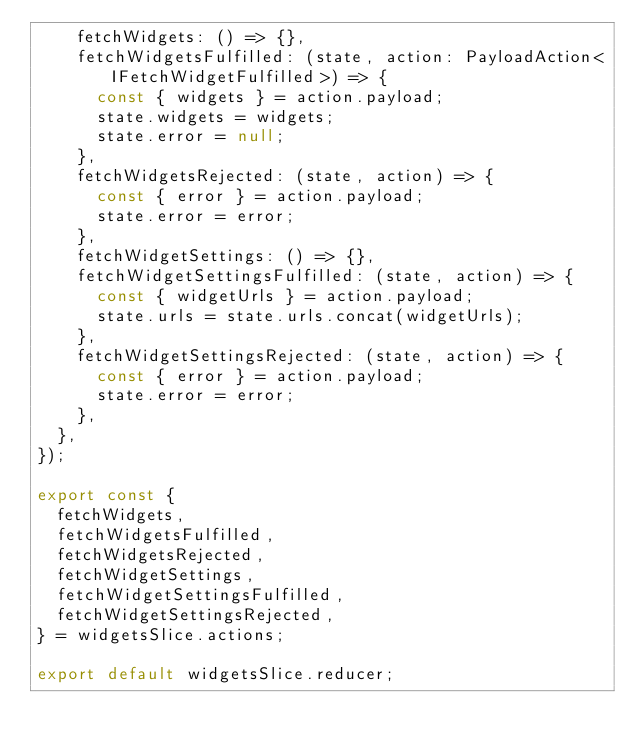Convert code to text. <code><loc_0><loc_0><loc_500><loc_500><_TypeScript_>    fetchWidgets: () => {},
    fetchWidgetsFulfilled: (state, action: PayloadAction<IFetchWidgetFulfilled>) => {
      const { widgets } = action.payload;
      state.widgets = widgets;
      state.error = null;
    },
    fetchWidgetsRejected: (state, action) => {
      const { error } = action.payload;
      state.error = error;
    },
    fetchWidgetSettings: () => {},
    fetchWidgetSettingsFulfilled: (state, action) => {
      const { widgetUrls } = action.payload;
      state.urls = state.urls.concat(widgetUrls);
    },
    fetchWidgetSettingsRejected: (state, action) => {
      const { error } = action.payload;
      state.error = error;
    },
  },
});

export const {
  fetchWidgets,
  fetchWidgetsFulfilled,
  fetchWidgetsRejected,
  fetchWidgetSettings,
  fetchWidgetSettingsFulfilled,
  fetchWidgetSettingsRejected,
} = widgetsSlice.actions;

export default widgetsSlice.reducer;
</code> 